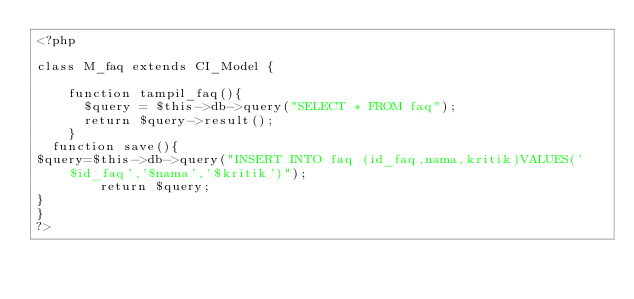Convert code to text. <code><loc_0><loc_0><loc_500><loc_500><_PHP_><?php 

class M_faq extends CI_Model {

    function tampil_faq(){
      $query = $this->db->query("SELECT * FROM faq");
      return $query->result();
    }
  function save(){
$query=$this->db->query("INSERT INTO faq (id_faq,nama,kritik)VALUES('$id_faq','$nama','$kritik')");
        return $query;
}
}
?></code> 